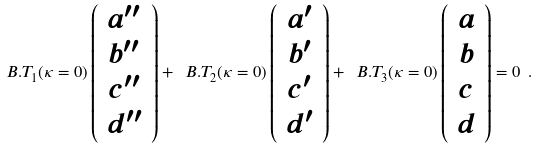Convert formula to latex. <formula><loc_0><loc_0><loc_500><loc_500>\ B . T _ { 1 } ( \kappa = 0 ) \left ( \begin{array} { c } a ^ { \prime \prime } \\ b ^ { \prime \prime } \\ c ^ { \prime \prime } \\ d ^ { \prime \prime } \end{array} \right ) + \ B . T _ { 2 } ( \kappa = 0 ) \left ( \begin{array} { c } a ^ { \prime } \\ b ^ { \prime } \\ c ^ { \prime } \\ d ^ { \prime } \end{array} \right ) + \ B . T _ { 3 } ( \kappa = 0 ) \left ( \begin{array} { c } a \\ b \\ c \\ d \end{array} \right ) = 0 \ .</formula> 